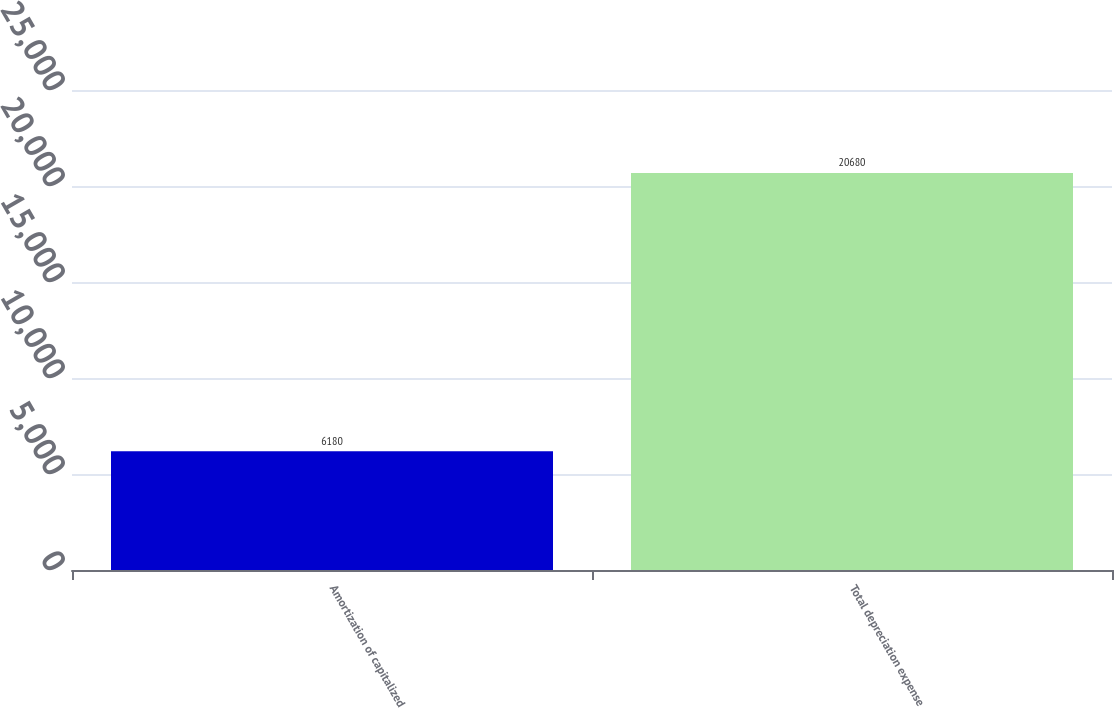Convert chart to OTSL. <chart><loc_0><loc_0><loc_500><loc_500><bar_chart><fcel>Amortization of capitalized<fcel>Total depreciation expense<nl><fcel>6180<fcel>20680<nl></chart> 